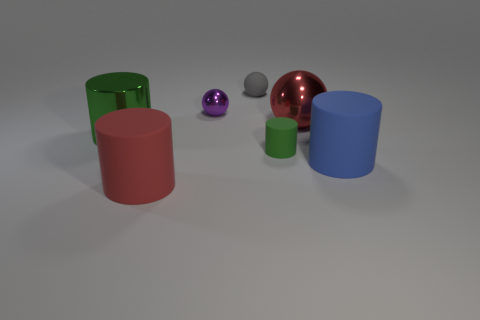There is a gray thing that is the same shape as the large red shiny object; what material is it?
Ensure brevity in your answer.  Rubber. Do the blue cylinder and the tiny green cylinder have the same material?
Give a very brief answer. Yes. Are there more red spheres to the left of the large red metal sphere than red spheres?
Offer a very short reply. No. What material is the tiny cylinder in front of the metallic ball that is right of the tiny gray thing that is on the left side of the large blue rubber cylinder made of?
Offer a terse response. Rubber. What number of things are cyan shiny blocks or objects behind the shiny cylinder?
Your response must be concise. 3. There is a big metal object behind the large green metal object; does it have the same color as the large shiny cylinder?
Your answer should be very brief. No. Is the number of small gray objects that are to the right of the small green rubber cylinder greater than the number of small objects that are right of the purple sphere?
Your answer should be compact. No. Is there anything else that is the same color as the small cylinder?
Provide a short and direct response. Yes. What number of things are red cylinders or blue rubber things?
Make the answer very short. 2. There is a metal thing behind the red metal object; does it have the same size as the large blue rubber cylinder?
Ensure brevity in your answer.  No. 